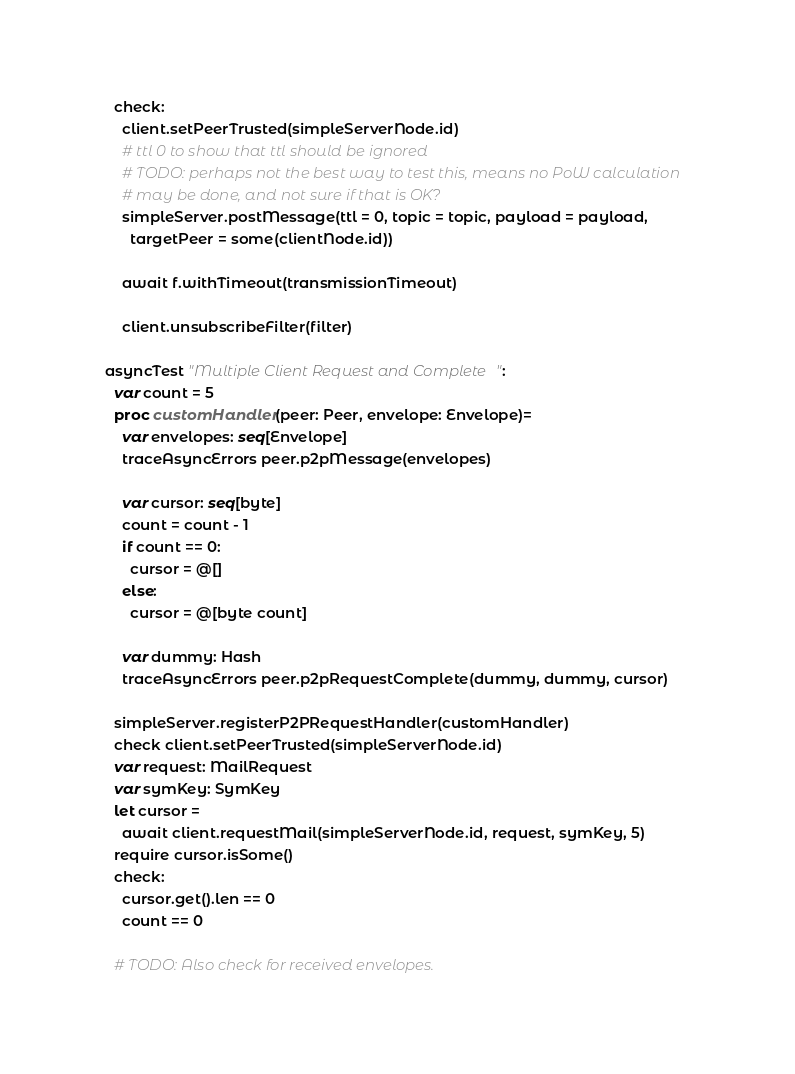<code> <loc_0><loc_0><loc_500><loc_500><_Nim_>    check:
      client.setPeerTrusted(simpleServerNode.id)
      # ttl 0 to show that ttl should be ignored
      # TODO: perhaps not the best way to test this, means no PoW calculation
      # may be done, and not sure if that is OK?
      simpleServer.postMessage(ttl = 0, topic = topic, payload = payload,
        targetPeer = some(clientNode.id))

      await f.withTimeout(transmissionTimeout)

      client.unsubscribeFilter(filter)

  asyncTest "Multiple Client Request and Complete":
    var count = 5
    proc customHandler(peer: Peer, envelope: Envelope)=
      var envelopes: seq[Envelope]
      traceAsyncErrors peer.p2pMessage(envelopes)

      var cursor: seq[byte]
      count = count - 1
      if count == 0:
        cursor = @[]
      else:
        cursor = @[byte count]

      var dummy: Hash
      traceAsyncErrors peer.p2pRequestComplete(dummy, dummy, cursor)

    simpleServer.registerP2PRequestHandler(customHandler)
    check client.setPeerTrusted(simpleServerNode.id)
    var request: MailRequest
    var symKey: SymKey
    let cursor =
      await client.requestMail(simpleServerNode.id, request, symKey, 5)
    require cursor.isSome()
    check:
      cursor.get().len == 0
      count == 0

    # TODO: Also check for received envelopes.
</code> 